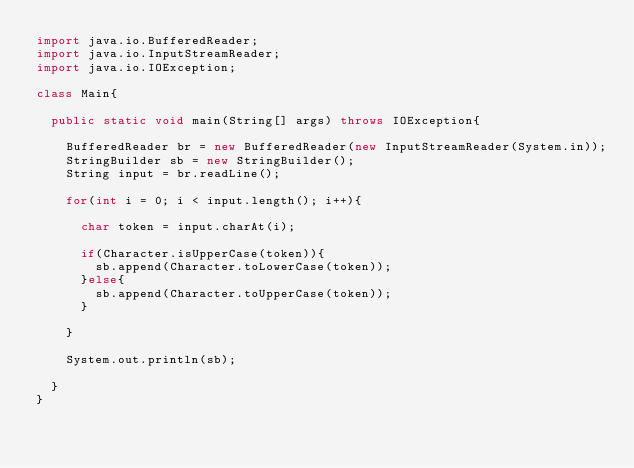<code> <loc_0><loc_0><loc_500><loc_500><_Java_>import java.io.BufferedReader;
import java.io.InputStreamReader;
import java.io.IOException;

class Main{

	public static void main(String[] args) throws IOException{

		BufferedReader br = new BufferedReader(new InputStreamReader(System.in));
		StringBuilder sb = new StringBuilder();
		String input = br.readLine();

		for(int i = 0; i < input.length(); i++){

			char token = input.charAt(i);

			if(Character.isUpperCase(token)){
				sb.append(Character.toLowerCase(token));
			}else{
				sb.append(Character.toUpperCase(token));
			}

		}

		System.out.println(sb);

	}
}</code> 